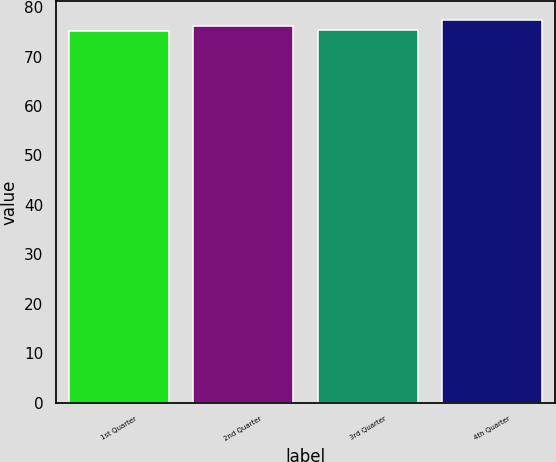Convert chart. <chart><loc_0><loc_0><loc_500><loc_500><bar_chart><fcel>1st Quarter<fcel>2nd Quarter<fcel>3rd Quarter<fcel>4th Quarter<nl><fcel>75.13<fcel>76.28<fcel>75.35<fcel>77.37<nl></chart> 